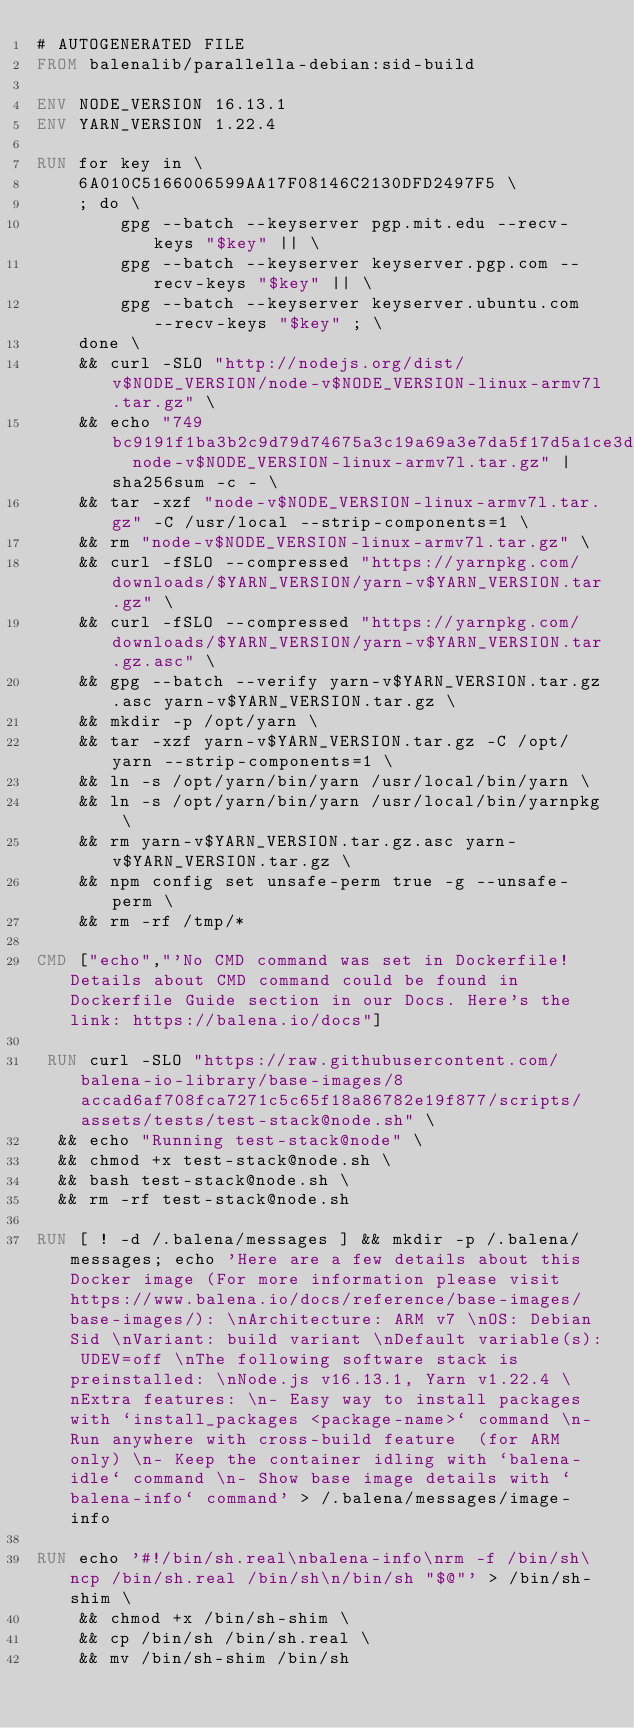Convert code to text. <code><loc_0><loc_0><loc_500><loc_500><_Dockerfile_># AUTOGENERATED FILE
FROM balenalib/parallella-debian:sid-build

ENV NODE_VERSION 16.13.1
ENV YARN_VERSION 1.22.4

RUN for key in \
	6A010C5166006599AA17F08146C2130DFD2497F5 \
	; do \
		gpg --batch --keyserver pgp.mit.edu --recv-keys "$key" || \
		gpg --batch --keyserver keyserver.pgp.com --recv-keys "$key" || \
		gpg --batch --keyserver keyserver.ubuntu.com --recv-keys "$key" ; \
	done \
	&& curl -SLO "http://nodejs.org/dist/v$NODE_VERSION/node-v$NODE_VERSION-linux-armv7l.tar.gz" \
	&& echo "749bc9191f1ba3b2c9d79d74675a3c19a69a3e7da5f17d5a1ce3d05a6cbef88e  node-v$NODE_VERSION-linux-armv7l.tar.gz" | sha256sum -c - \
	&& tar -xzf "node-v$NODE_VERSION-linux-armv7l.tar.gz" -C /usr/local --strip-components=1 \
	&& rm "node-v$NODE_VERSION-linux-armv7l.tar.gz" \
	&& curl -fSLO --compressed "https://yarnpkg.com/downloads/$YARN_VERSION/yarn-v$YARN_VERSION.tar.gz" \
	&& curl -fSLO --compressed "https://yarnpkg.com/downloads/$YARN_VERSION/yarn-v$YARN_VERSION.tar.gz.asc" \
	&& gpg --batch --verify yarn-v$YARN_VERSION.tar.gz.asc yarn-v$YARN_VERSION.tar.gz \
	&& mkdir -p /opt/yarn \
	&& tar -xzf yarn-v$YARN_VERSION.tar.gz -C /opt/yarn --strip-components=1 \
	&& ln -s /opt/yarn/bin/yarn /usr/local/bin/yarn \
	&& ln -s /opt/yarn/bin/yarn /usr/local/bin/yarnpkg \
	&& rm yarn-v$YARN_VERSION.tar.gz.asc yarn-v$YARN_VERSION.tar.gz \
	&& npm config set unsafe-perm true -g --unsafe-perm \
	&& rm -rf /tmp/*

CMD ["echo","'No CMD command was set in Dockerfile! Details about CMD command could be found in Dockerfile Guide section in our Docs. Here's the link: https://balena.io/docs"]

 RUN curl -SLO "https://raw.githubusercontent.com/balena-io-library/base-images/8accad6af708fca7271c5c65f18a86782e19f877/scripts/assets/tests/test-stack@node.sh" \
  && echo "Running test-stack@node" \
  && chmod +x test-stack@node.sh \
  && bash test-stack@node.sh \
  && rm -rf test-stack@node.sh 

RUN [ ! -d /.balena/messages ] && mkdir -p /.balena/messages; echo 'Here are a few details about this Docker image (For more information please visit https://www.balena.io/docs/reference/base-images/base-images/): \nArchitecture: ARM v7 \nOS: Debian Sid \nVariant: build variant \nDefault variable(s): UDEV=off \nThe following software stack is preinstalled: \nNode.js v16.13.1, Yarn v1.22.4 \nExtra features: \n- Easy way to install packages with `install_packages <package-name>` command \n- Run anywhere with cross-build feature  (for ARM only) \n- Keep the container idling with `balena-idle` command \n- Show base image details with `balena-info` command' > /.balena/messages/image-info

RUN echo '#!/bin/sh.real\nbalena-info\nrm -f /bin/sh\ncp /bin/sh.real /bin/sh\n/bin/sh "$@"' > /bin/sh-shim \
	&& chmod +x /bin/sh-shim \
	&& cp /bin/sh /bin/sh.real \
	&& mv /bin/sh-shim /bin/sh</code> 